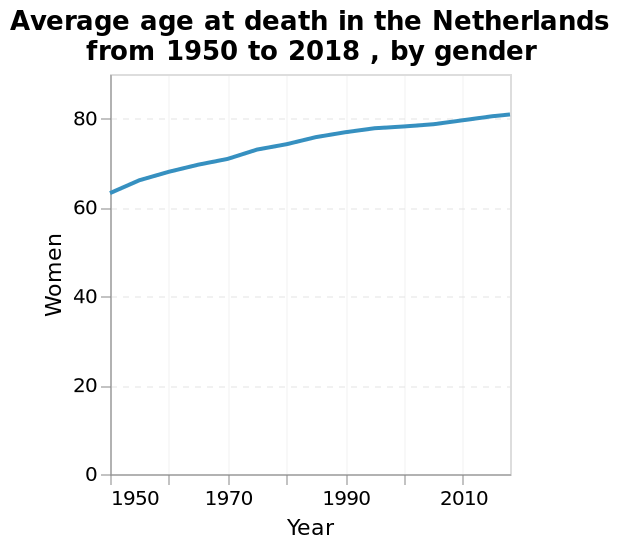<image>
What is the minimum value shown on the y-axis?  The minimum value on the y-axis is 0, suggesting that there were cases where women did not reach the age of death during the mentioned years. 